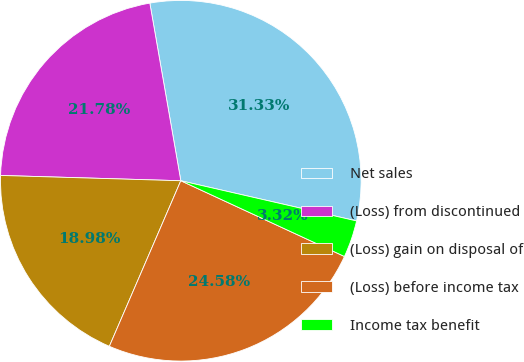Convert chart to OTSL. <chart><loc_0><loc_0><loc_500><loc_500><pie_chart><fcel>Net sales<fcel>(Loss) from discontinued<fcel>(Loss) gain on disposal of<fcel>(Loss) before income tax<fcel>Income tax benefit<nl><fcel>31.32%<fcel>21.78%<fcel>18.98%<fcel>24.58%<fcel>3.32%<nl></chart> 